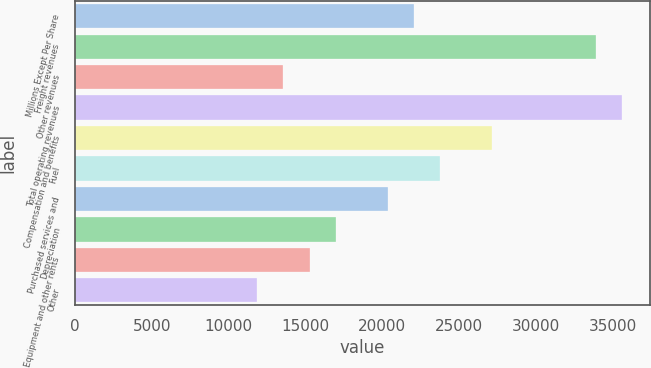Convert chart to OTSL. <chart><loc_0><loc_0><loc_500><loc_500><bar_chart><fcel>Millions Except Per Share<fcel>Freight revenues<fcel>Other revenues<fcel>Total operating revenues<fcel>Compensation and benefits<fcel>Fuel<fcel>Purchased services and<fcel>Depreciation<fcel>Equipment and other rents<fcel>Other<nl><fcel>22054.1<fcel>33928.7<fcel>13572.3<fcel>35625.1<fcel>27143.2<fcel>23750.5<fcel>20357.8<fcel>16965<fcel>15268.6<fcel>11875.9<nl></chart> 